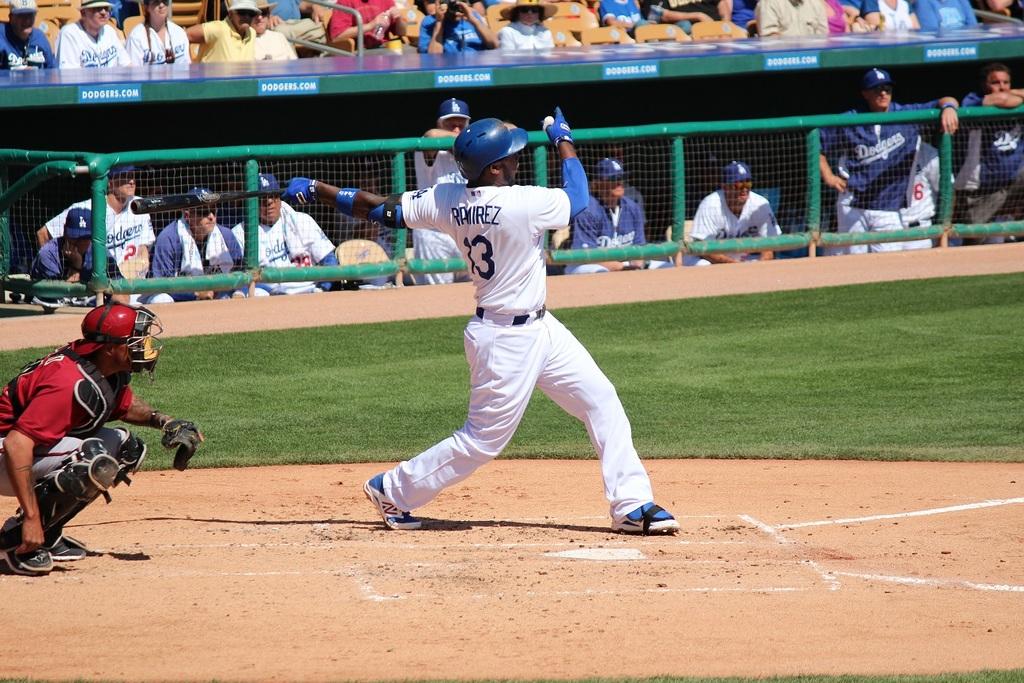What is the batter's last name?
Offer a very short reply. Ramirez. What team is in the dugout?
Offer a very short reply. Dodgers. 